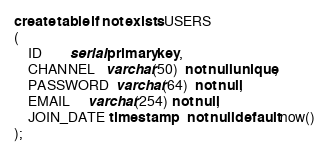<code> <loc_0><loc_0><loc_500><loc_500><_SQL_>create table if not exists USERS
(
    ID        serial primary key,
    CHANNEL   varchar(50)  not null unique,
    PASSWORD  varchar(64)  not null,
    EMAIL     varchar(254) not null,
    JOIN_DATE timestamp    not null default now()
);
</code> 